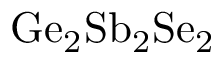Convert formula to latex. <formula><loc_0><loc_0><loc_500><loc_500>G e _ { 2 } S b _ { 2 } S e _ { 2 }</formula> 